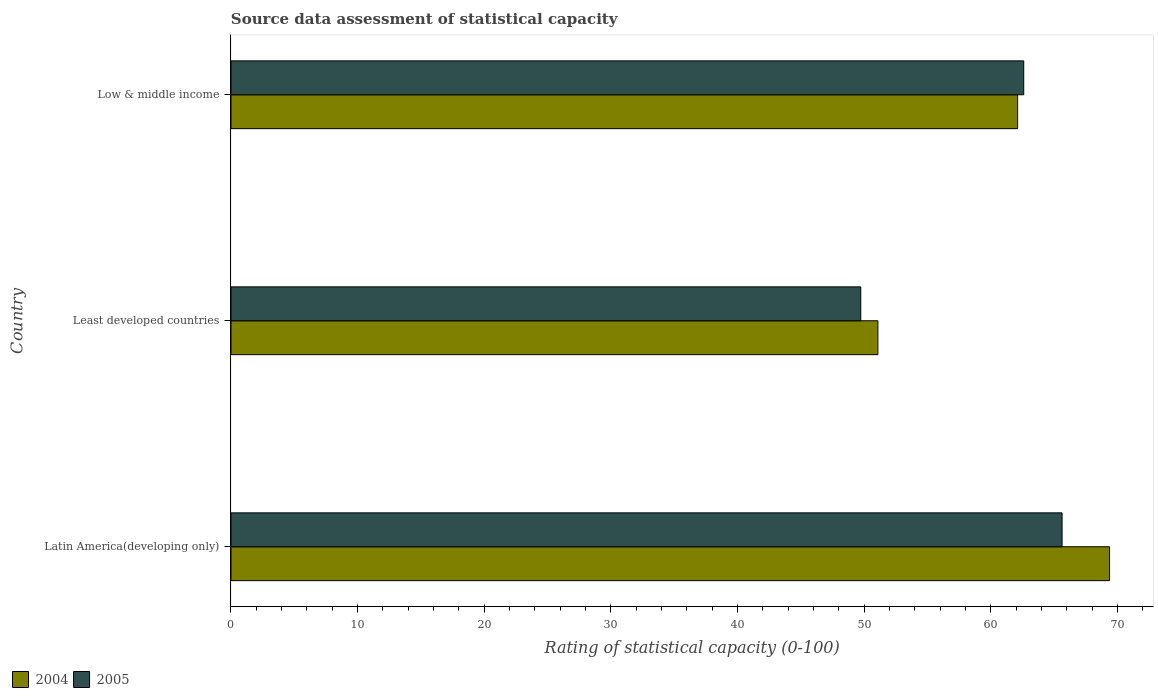How many different coloured bars are there?
Provide a succinct answer. 2. How many bars are there on the 2nd tick from the bottom?
Provide a succinct answer. 2. What is the label of the 2nd group of bars from the top?
Your answer should be very brief. Least developed countries. In how many cases, is the number of bars for a given country not equal to the number of legend labels?
Ensure brevity in your answer.  0. What is the rating of statistical capacity in 2004 in Latin America(developing only)?
Provide a short and direct response. 69.38. Across all countries, what is the maximum rating of statistical capacity in 2005?
Give a very brief answer. 65.62. Across all countries, what is the minimum rating of statistical capacity in 2005?
Your response must be concise. 49.73. In which country was the rating of statistical capacity in 2004 maximum?
Your answer should be compact. Latin America(developing only). In which country was the rating of statistical capacity in 2004 minimum?
Your answer should be very brief. Least developed countries. What is the total rating of statistical capacity in 2004 in the graph?
Your answer should be very brief. 182.57. What is the difference between the rating of statistical capacity in 2004 in Least developed countries and that in Low & middle income?
Make the answer very short. -11.03. What is the difference between the rating of statistical capacity in 2005 in Low & middle income and the rating of statistical capacity in 2004 in Latin America(developing only)?
Offer a terse response. -6.78. What is the average rating of statistical capacity in 2005 per country?
Offer a terse response. 59.32. What is the difference between the rating of statistical capacity in 2005 and rating of statistical capacity in 2004 in Least developed countries?
Give a very brief answer. -1.35. What is the ratio of the rating of statistical capacity in 2004 in Latin America(developing only) to that in Low & middle income?
Keep it short and to the point. 1.12. What is the difference between the highest and the second highest rating of statistical capacity in 2004?
Keep it short and to the point. 7.26. What is the difference between the highest and the lowest rating of statistical capacity in 2005?
Make the answer very short. 15.9. In how many countries, is the rating of statistical capacity in 2004 greater than the average rating of statistical capacity in 2004 taken over all countries?
Make the answer very short. 2. What does the 2nd bar from the top in Least developed countries represents?
Your answer should be compact. 2004. What does the 2nd bar from the bottom in Latin America(developing only) represents?
Provide a succinct answer. 2005. Are all the bars in the graph horizontal?
Make the answer very short. Yes. What is the difference between two consecutive major ticks on the X-axis?
Provide a short and direct response. 10. Are the values on the major ticks of X-axis written in scientific E-notation?
Offer a very short reply. No. Does the graph contain grids?
Ensure brevity in your answer.  No. How many legend labels are there?
Give a very brief answer. 2. What is the title of the graph?
Make the answer very short. Source data assessment of statistical capacity. What is the label or title of the X-axis?
Give a very brief answer. Rating of statistical capacity (0-100). What is the label or title of the Y-axis?
Offer a terse response. Country. What is the Rating of statistical capacity (0-100) of 2004 in Latin America(developing only)?
Give a very brief answer. 69.38. What is the Rating of statistical capacity (0-100) of 2005 in Latin America(developing only)?
Give a very brief answer. 65.62. What is the Rating of statistical capacity (0-100) in 2004 in Least developed countries?
Your answer should be very brief. 51.08. What is the Rating of statistical capacity (0-100) of 2005 in Least developed countries?
Your response must be concise. 49.73. What is the Rating of statistical capacity (0-100) of 2004 in Low & middle income?
Make the answer very short. 62.12. What is the Rating of statistical capacity (0-100) in 2005 in Low & middle income?
Your answer should be compact. 62.6. Across all countries, what is the maximum Rating of statistical capacity (0-100) of 2004?
Give a very brief answer. 69.38. Across all countries, what is the maximum Rating of statistical capacity (0-100) in 2005?
Offer a terse response. 65.62. Across all countries, what is the minimum Rating of statistical capacity (0-100) of 2004?
Offer a terse response. 51.08. Across all countries, what is the minimum Rating of statistical capacity (0-100) of 2005?
Ensure brevity in your answer.  49.73. What is the total Rating of statistical capacity (0-100) of 2004 in the graph?
Give a very brief answer. 182.57. What is the total Rating of statistical capacity (0-100) in 2005 in the graph?
Your response must be concise. 177.95. What is the difference between the Rating of statistical capacity (0-100) in 2004 in Latin America(developing only) and that in Least developed countries?
Your answer should be very brief. 18.29. What is the difference between the Rating of statistical capacity (0-100) in 2005 in Latin America(developing only) and that in Least developed countries?
Keep it short and to the point. 15.9. What is the difference between the Rating of statistical capacity (0-100) in 2004 in Latin America(developing only) and that in Low & middle income?
Give a very brief answer. 7.26. What is the difference between the Rating of statistical capacity (0-100) in 2005 in Latin America(developing only) and that in Low & middle income?
Provide a succinct answer. 3.03. What is the difference between the Rating of statistical capacity (0-100) of 2004 in Least developed countries and that in Low & middle income?
Your response must be concise. -11.03. What is the difference between the Rating of statistical capacity (0-100) of 2005 in Least developed countries and that in Low & middle income?
Provide a short and direct response. -12.87. What is the difference between the Rating of statistical capacity (0-100) of 2004 in Latin America(developing only) and the Rating of statistical capacity (0-100) of 2005 in Least developed countries?
Provide a short and direct response. 19.65. What is the difference between the Rating of statistical capacity (0-100) in 2004 in Latin America(developing only) and the Rating of statistical capacity (0-100) in 2005 in Low & middle income?
Make the answer very short. 6.78. What is the difference between the Rating of statistical capacity (0-100) of 2004 in Least developed countries and the Rating of statistical capacity (0-100) of 2005 in Low & middle income?
Offer a very short reply. -11.52. What is the average Rating of statistical capacity (0-100) of 2004 per country?
Offer a terse response. 60.86. What is the average Rating of statistical capacity (0-100) of 2005 per country?
Keep it short and to the point. 59.32. What is the difference between the Rating of statistical capacity (0-100) of 2004 and Rating of statistical capacity (0-100) of 2005 in Latin America(developing only)?
Ensure brevity in your answer.  3.75. What is the difference between the Rating of statistical capacity (0-100) in 2004 and Rating of statistical capacity (0-100) in 2005 in Least developed countries?
Ensure brevity in your answer.  1.35. What is the difference between the Rating of statistical capacity (0-100) of 2004 and Rating of statistical capacity (0-100) of 2005 in Low & middle income?
Ensure brevity in your answer.  -0.48. What is the ratio of the Rating of statistical capacity (0-100) of 2004 in Latin America(developing only) to that in Least developed countries?
Give a very brief answer. 1.36. What is the ratio of the Rating of statistical capacity (0-100) in 2005 in Latin America(developing only) to that in Least developed countries?
Give a very brief answer. 1.32. What is the ratio of the Rating of statistical capacity (0-100) of 2004 in Latin America(developing only) to that in Low & middle income?
Offer a terse response. 1.12. What is the ratio of the Rating of statistical capacity (0-100) in 2005 in Latin America(developing only) to that in Low & middle income?
Your response must be concise. 1.05. What is the ratio of the Rating of statistical capacity (0-100) in 2004 in Least developed countries to that in Low & middle income?
Keep it short and to the point. 0.82. What is the ratio of the Rating of statistical capacity (0-100) in 2005 in Least developed countries to that in Low & middle income?
Make the answer very short. 0.79. What is the difference between the highest and the second highest Rating of statistical capacity (0-100) of 2004?
Your answer should be compact. 7.26. What is the difference between the highest and the second highest Rating of statistical capacity (0-100) in 2005?
Offer a very short reply. 3.03. What is the difference between the highest and the lowest Rating of statistical capacity (0-100) of 2004?
Provide a succinct answer. 18.29. What is the difference between the highest and the lowest Rating of statistical capacity (0-100) of 2005?
Ensure brevity in your answer.  15.9. 